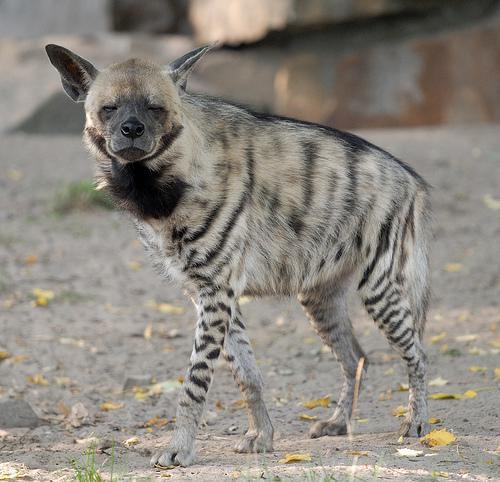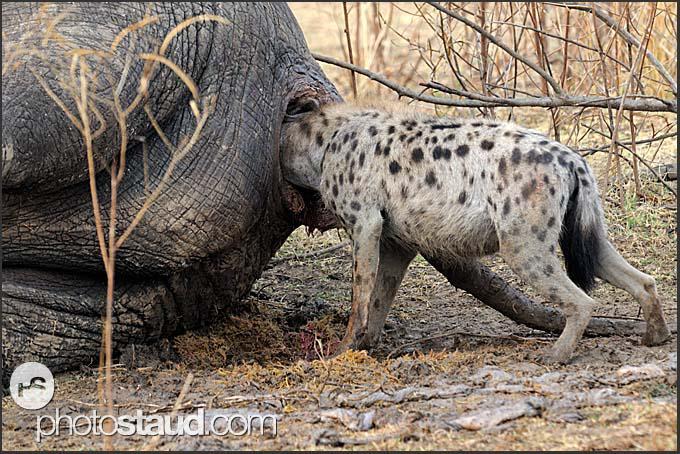The first image is the image on the left, the second image is the image on the right. Evaluate the accuracy of this statement regarding the images: "1 dog has a paw that is not touching the ground.". Is it true? Answer yes or no. No. The first image is the image on the left, the second image is the image on the right. Analyze the images presented: Is the assertion "Two hyenas are standing and facing opposite each other." valid? Answer yes or no. No. 